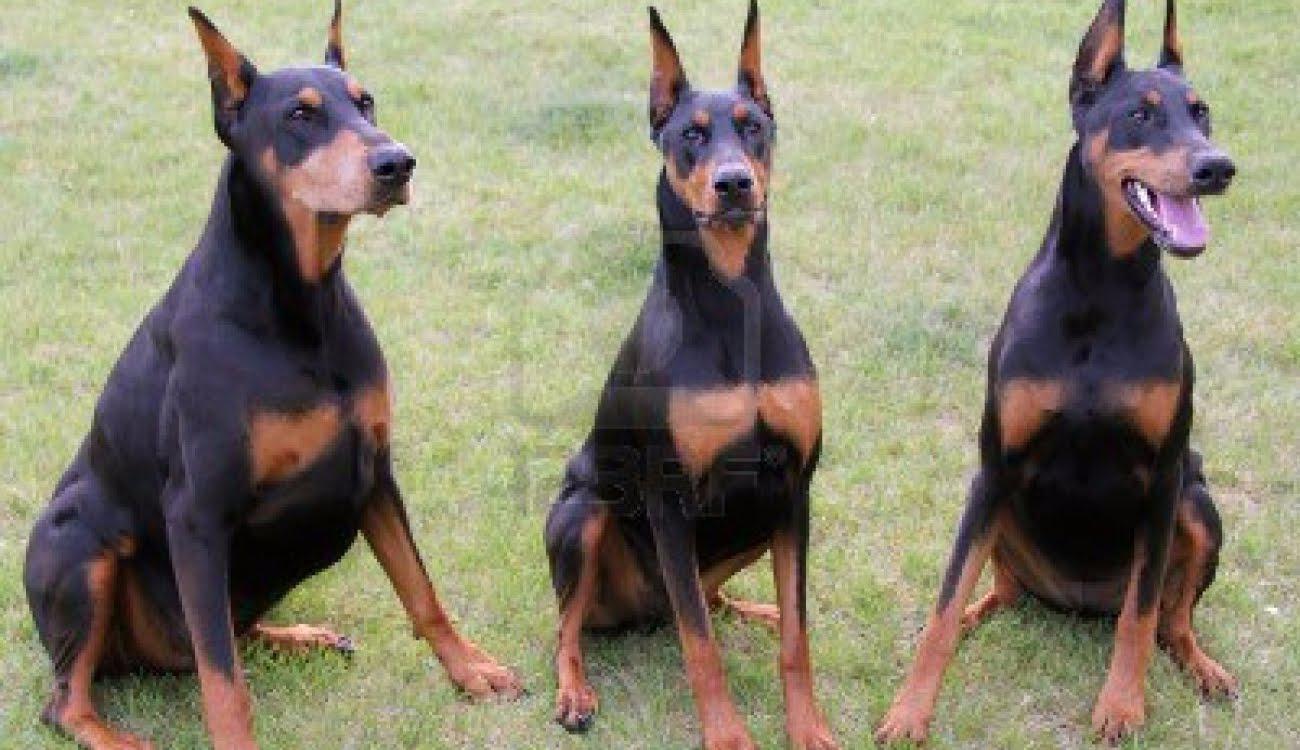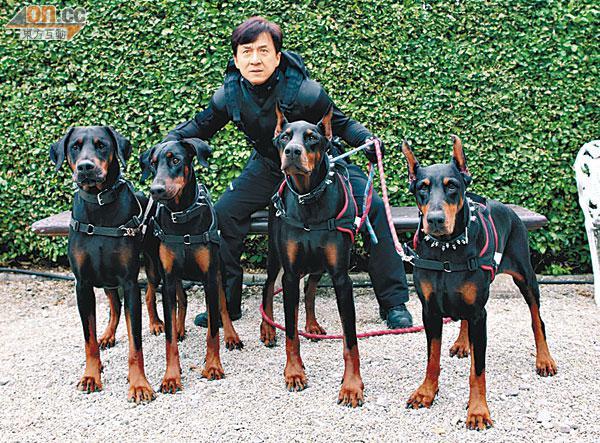The first image is the image on the left, the second image is the image on the right. For the images displayed, is the sentence "there are 5 dogs sitting in a row on the grass while wearing collars" factually correct? Answer yes or no. No. 